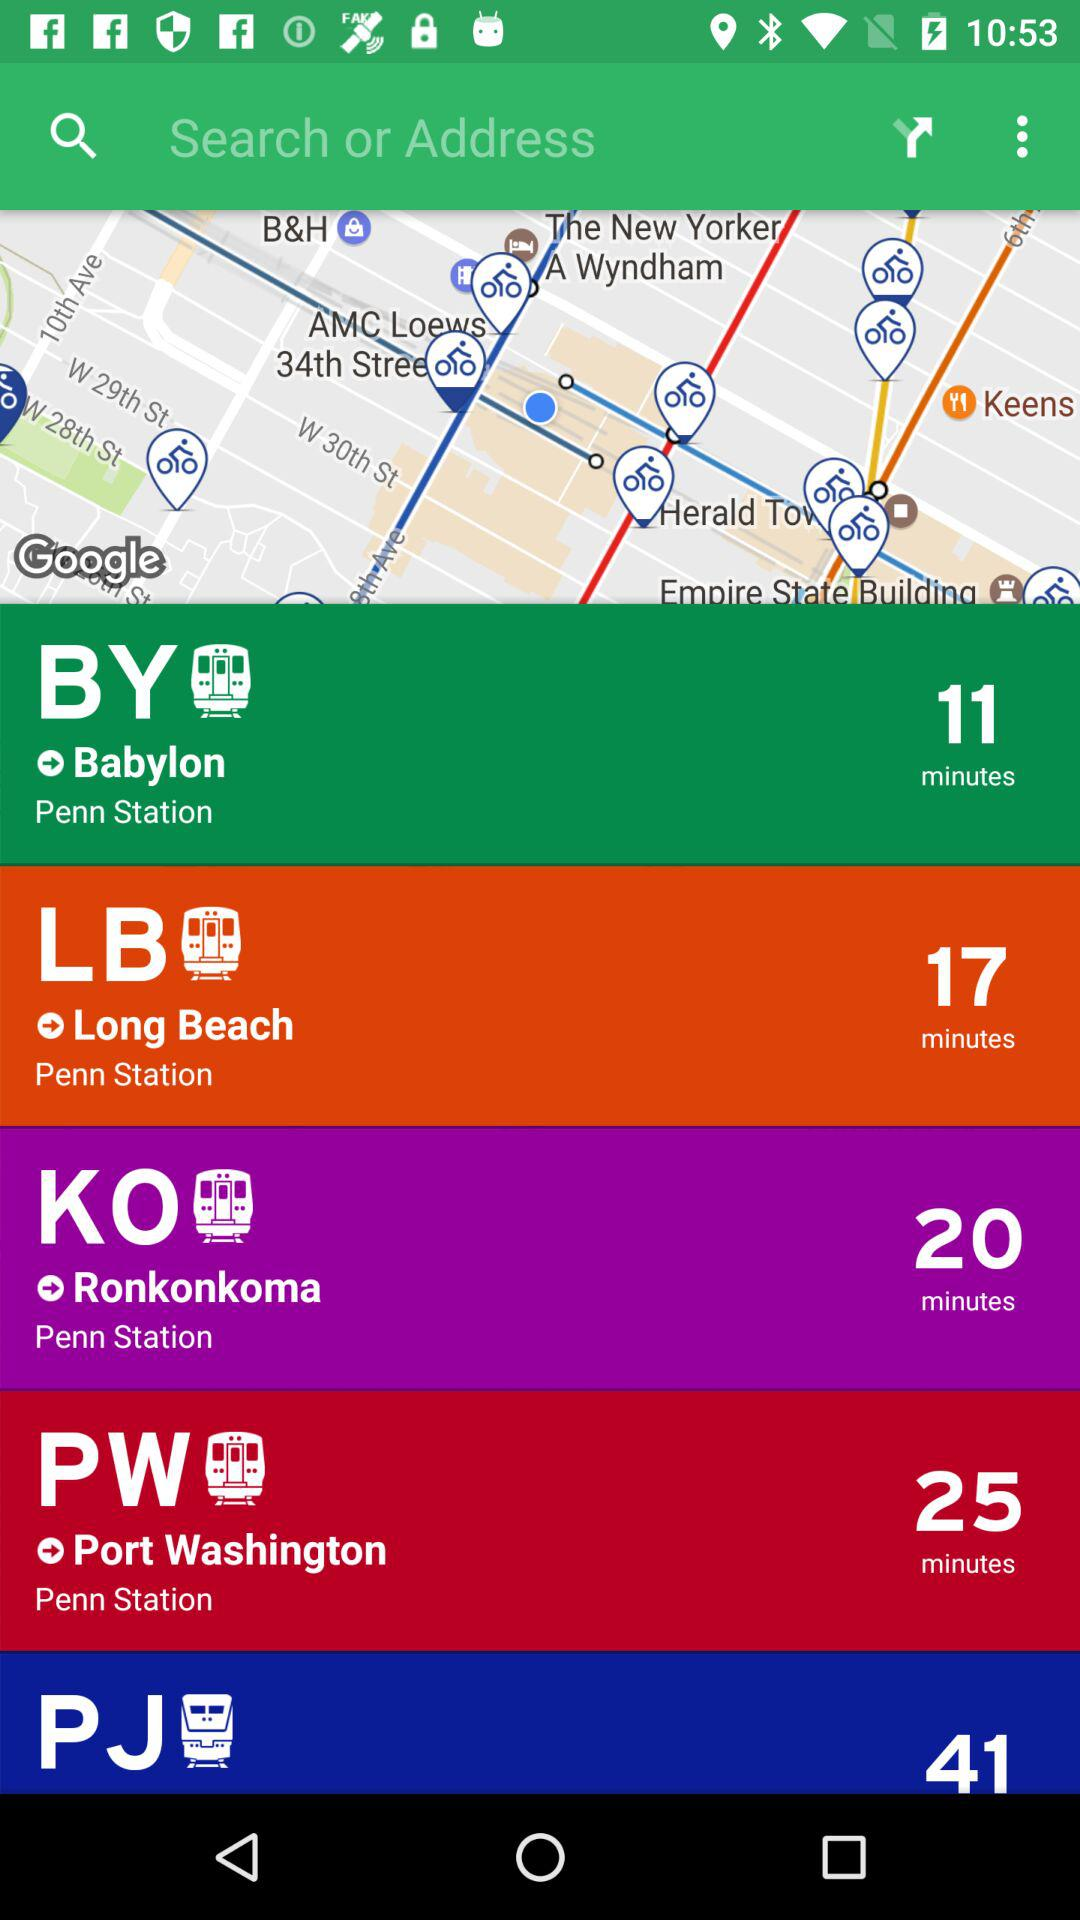What is the journey time from "Penn Station" to "Babylon"? The journey time from "Penn Station" to "Babylon" is 11 minutes. 